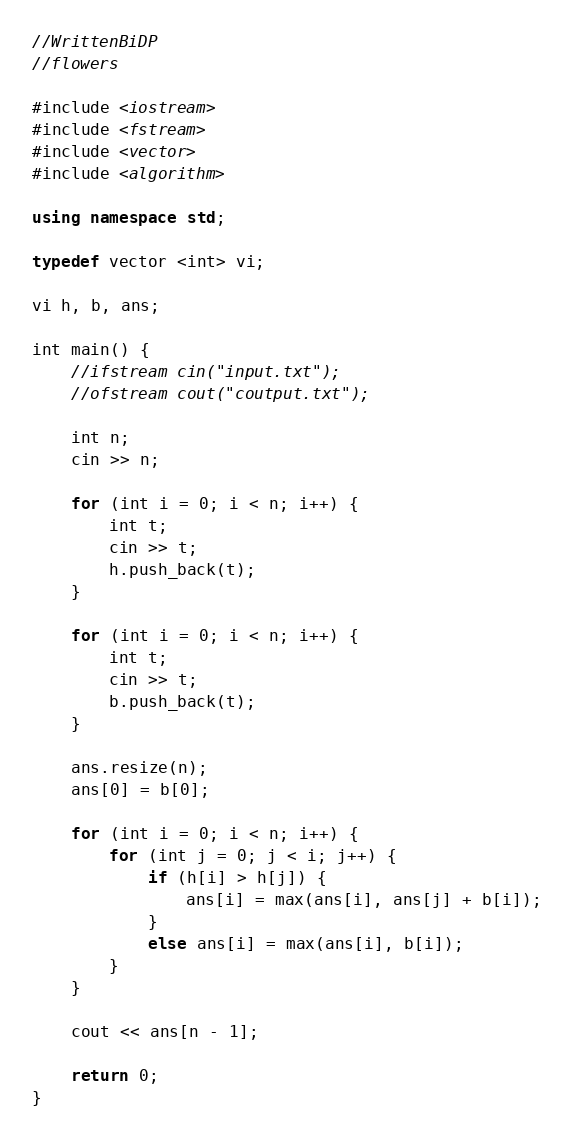<code> <loc_0><loc_0><loc_500><loc_500><_C++_>//WrittenBiDP
//flowers

#include <iostream>
#include <fstream>
#include <vector>
#include <algorithm>

using namespace std;

typedef vector <int> vi;

vi h, b, ans;

int main() {
	//ifstream cin("input.txt");
	//ofstream cout("coutput.txt");

	int n;
	cin >> n;

	for (int i = 0; i < n; i++) {
		int t;
		cin >> t;
		h.push_back(t);
	}

	for (int i = 0; i < n; i++) {
		int t;
		cin >> t;
		b.push_back(t);
	}

	ans.resize(n);
	ans[0] = b[0];

	for (int i = 0; i < n; i++) {
		for (int j = 0; j < i; j++) {
			if (h[i] > h[j]) {
				ans[i] = max(ans[i], ans[j] + b[i]);
			}
			else ans[i] = max(ans[i], b[i]);
		}
	}

	cout << ans[n - 1];

	return 0;
}</code> 